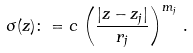Convert formula to latex. <formula><loc_0><loc_0><loc_500><loc_500>\sigma ( z ) \colon = c \, \left ( \frac { | z - z _ { j } | } { r _ { j } } \right ) ^ { m _ { j } } \, .</formula> 